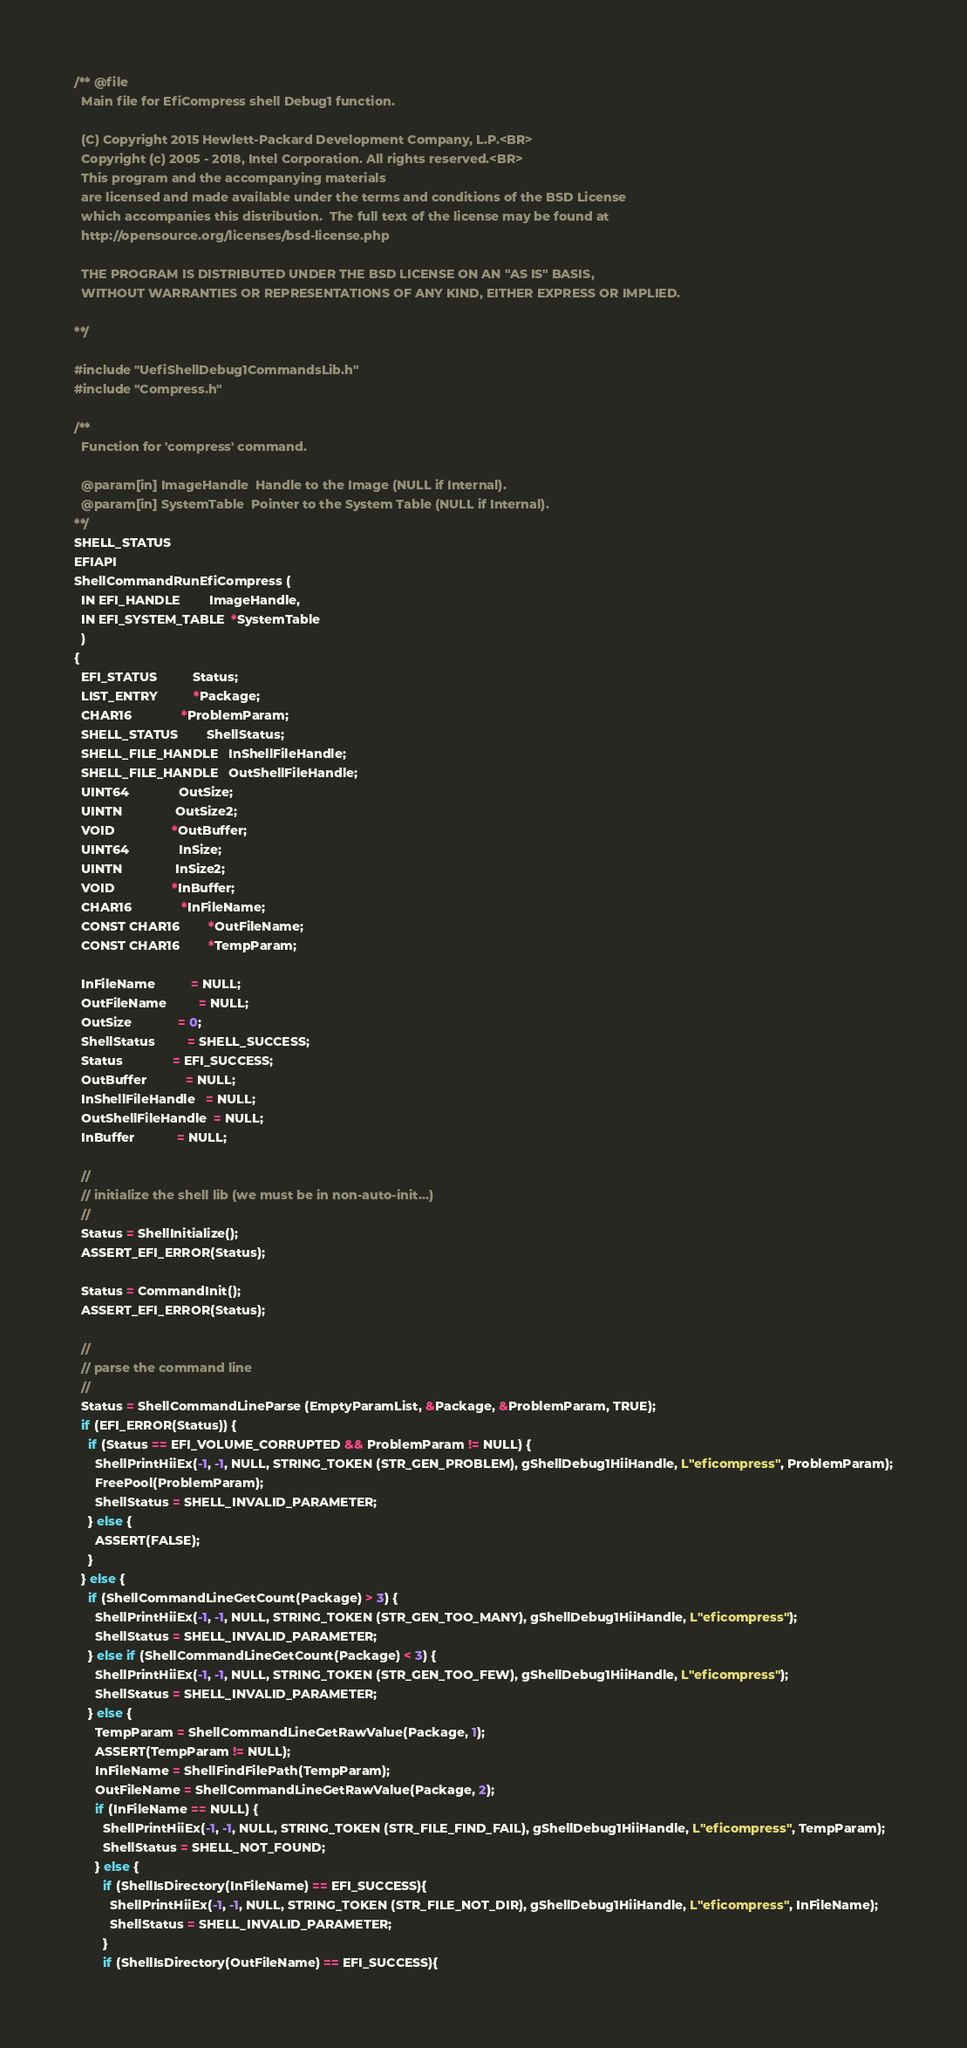<code> <loc_0><loc_0><loc_500><loc_500><_C_>/** @file
  Main file for EfiCompress shell Debug1 function.

  (C) Copyright 2015 Hewlett-Packard Development Company, L.P.<BR>
  Copyright (c) 2005 - 2018, Intel Corporation. All rights reserved.<BR>
  This program and the accompanying materials
  are licensed and made available under the terms and conditions of the BSD License
  which accompanies this distribution.  The full text of the license may be found at
  http://opensource.org/licenses/bsd-license.php

  THE PROGRAM IS DISTRIBUTED UNDER THE BSD LICENSE ON AN "AS IS" BASIS,
  WITHOUT WARRANTIES OR REPRESENTATIONS OF ANY KIND, EITHER EXPRESS OR IMPLIED.

**/

#include "UefiShellDebug1CommandsLib.h"
#include "Compress.h"

/**
  Function for 'compress' command.

  @param[in] ImageHandle  Handle to the Image (NULL if Internal).
  @param[in] SystemTable  Pointer to the System Table (NULL if Internal).
**/
SHELL_STATUS
EFIAPI
ShellCommandRunEfiCompress (
  IN EFI_HANDLE        ImageHandle,
  IN EFI_SYSTEM_TABLE  *SystemTable
  )
{
  EFI_STATUS          Status;
  LIST_ENTRY          *Package;
  CHAR16              *ProblemParam;
  SHELL_STATUS        ShellStatus;
  SHELL_FILE_HANDLE   InShellFileHandle;
  SHELL_FILE_HANDLE   OutShellFileHandle;
  UINT64              OutSize;
  UINTN               OutSize2;
  VOID                *OutBuffer;
  UINT64              InSize;
  UINTN               InSize2;
  VOID                *InBuffer;
  CHAR16              *InFileName;
  CONST CHAR16        *OutFileName;
  CONST CHAR16        *TempParam;

  InFileName          = NULL;
  OutFileName         = NULL;
  OutSize             = 0;
  ShellStatus         = SHELL_SUCCESS;
  Status              = EFI_SUCCESS;
  OutBuffer           = NULL;
  InShellFileHandle   = NULL;
  OutShellFileHandle  = NULL;
  InBuffer            = NULL;

  //
  // initialize the shell lib (we must be in non-auto-init...)
  //
  Status = ShellInitialize();
  ASSERT_EFI_ERROR(Status);

  Status = CommandInit();
  ASSERT_EFI_ERROR(Status);

  //
  // parse the command line
  //
  Status = ShellCommandLineParse (EmptyParamList, &Package, &ProblemParam, TRUE);
  if (EFI_ERROR(Status)) {
    if (Status == EFI_VOLUME_CORRUPTED && ProblemParam != NULL) {
      ShellPrintHiiEx(-1, -1, NULL, STRING_TOKEN (STR_GEN_PROBLEM), gShellDebug1HiiHandle, L"eficompress", ProblemParam);
      FreePool(ProblemParam);
      ShellStatus = SHELL_INVALID_PARAMETER;
    } else {
      ASSERT(FALSE);
    }
  } else {
    if (ShellCommandLineGetCount(Package) > 3) {
      ShellPrintHiiEx(-1, -1, NULL, STRING_TOKEN (STR_GEN_TOO_MANY), gShellDebug1HiiHandle, L"eficompress");
      ShellStatus = SHELL_INVALID_PARAMETER;
    } else if (ShellCommandLineGetCount(Package) < 3) {
      ShellPrintHiiEx(-1, -1, NULL, STRING_TOKEN (STR_GEN_TOO_FEW), gShellDebug1HiiHandle, L"eficompress");
      ShellStatus = SHELL_INVALID_PARAMETER;
    } else {
      TempParam = ShellCommandLineGetRawValue(Package, 1);
      ASSERT(TempParam != NULL);
      InFileName = ShellFindFilePath(TempParam);
      OutFileName = ShellCommandLineGetRawValue(Package, 2);
      if (InFileName == NULL) {
        ShellPrintHiiEx(-1, -1, NULL, STRING_TOKEN (STR_FILE_FIND_FAIL), gShellDebug1HiiHandle, L"eficompress", TempParam);
        ShellStatus = SHELL_NOT_FOUND;
      } else {
        if (ShellIsDirectory(InFileName) == EFI_SUCCESS){
          ShellPrintHiiEx(-1, -1, NULL, STRING_TOKEN (STR_FILE_NOT_DIR), gShellDebug1HiiHandle, L"eficompress", InFileName);
          ShellStatus = SHELL_INVALID_PARAMETER;
        }
        if (ShellIsDirectory(OutFileName) == EFI_SUCCESS){</code> 